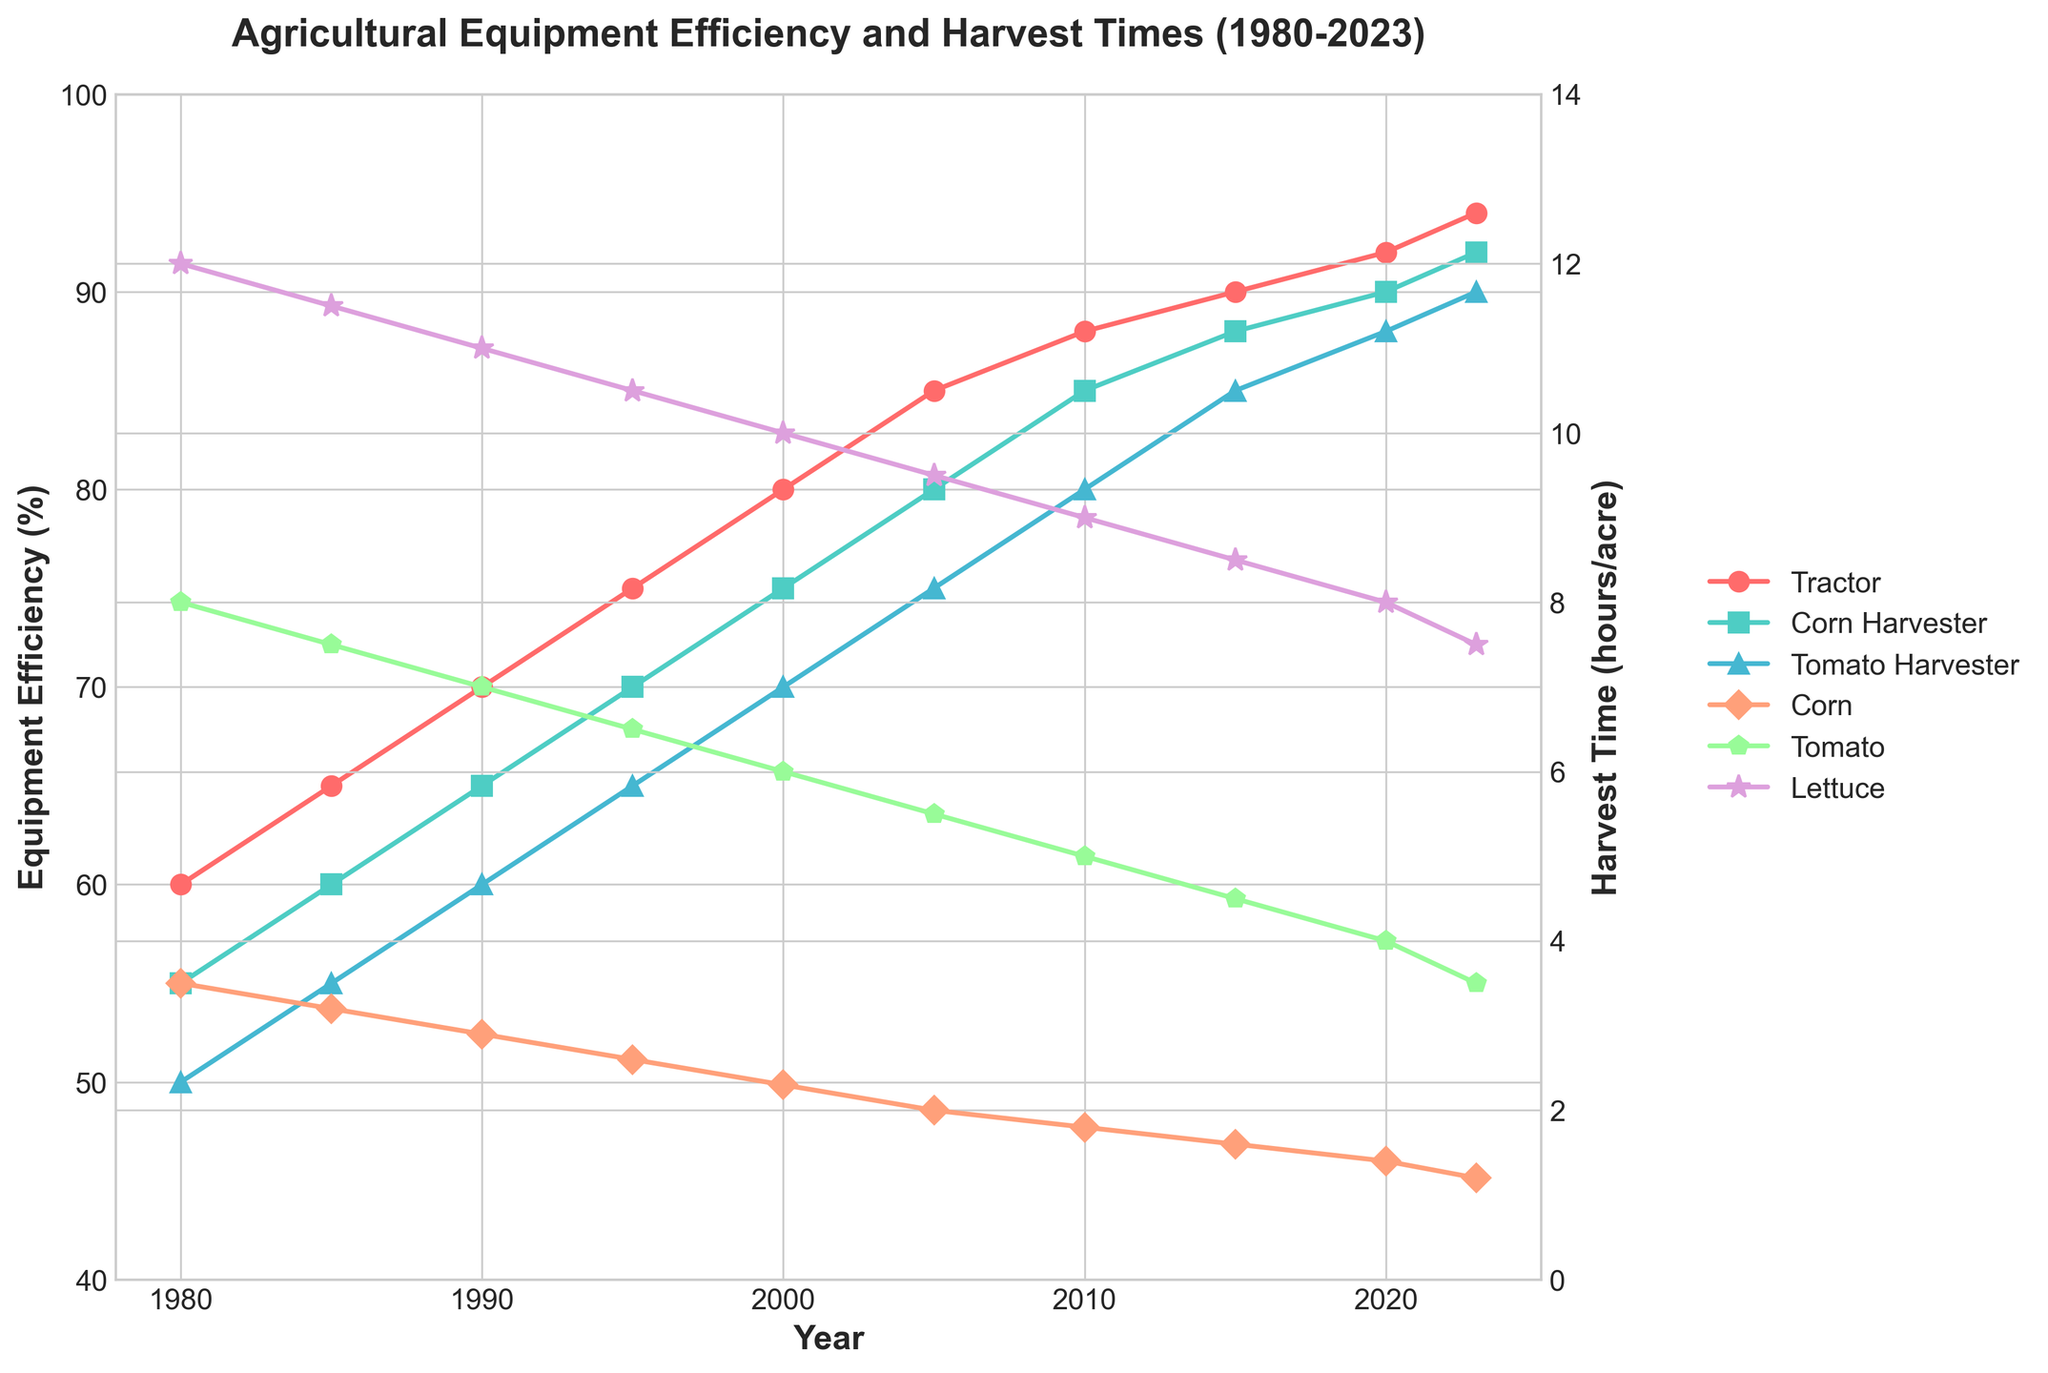What is the trend in tractor efficiency from 1980 to 2023? The tractor efficiency increases steadily over time from 60% in 1980 to 94% in 2023. Each data point shows a consistent rise, indicating a steady improvement in tractor efficiency.
Answer: Tractor efficiency steadily increases from 60% to 94% How does the cornharvester efficiency in 2000 compare to 2015? In 2000, the corn harvester efficiency is 75%. In 2015, it increases to 88%. Comparing these values, there is a noticeable increase in efficiency from 2000 to 2015.
Answer: Corn harvester efficiency increases from 75% to 88% Which year shows the biggest drop in lettuce harvest time compared to the previous year? Comparing each year's data, from 2015 to 2020, the lettuce harvest time dropped from 8.5 hours/acre to 8.0 hours/acre. This 0.5-hour drop is the largest seen in this period.
Answer: Between 2015 and 2020 What is the average improvement in tomato harvester efficiency every 5 years? From 1980 to 2023, tomato harvester efficiency improves from 50% to 90% over 43 years (2023-1980). The average improvement per year is (90-50)/43 = 0.93%. For every 5 years, it’s 0.93% * 5 = 4.65%.
Answer: Around 4.65% every 5 years Which crop saw the most significant reduction in harvest time from 1980 to 2023? Comparing the initial and final times for corn, tomato, and lettuce, Corn harvest time dropped from 3.5 hours/acre to 1.2, tomato from 8.0 to 3.5, and lettuce from 12.0 to 7.5 hours/acre. The largest change is in corn with a reduction of 2.3 hours/acre.
Answer: Corn What year did the corn harvester efficiency first reach 85%? The plot shows that corn harvester efficiency reaches 85% in the year 2010, as this is where the data point aligns with the 85% mark on the y-axis.
Answer: 2010 Compare the efficiency improvements between the corn harvester and the tomato harvester from 1990 to 2000. In 1990, corn harvester efficiency is 65% and in 2000, it is 75%, showing an increase of 10%. For the tomato harvester, the efficiency is 60% in 1990 and 70% in 2000, indicating the same 10% improvement.
Answer: Both improved by 10% Between which consecutive years did the tomato harvester efficiency see the greatest increase? By examining the data, the biggest increase in tomato harvester efficiency occurs between 2000 and 2005, where it increased from 70% to 75%.
Answer: Between 2000 and 2005 What is the relationship between equipment efficiency and harvest times for each crop? As equipment efficiency improves for tractors and harvesters, the harvest times for all crops (corn, tomato, lettuce) decrease consistently. This inverse relationship is evident as higher efficiency corresponds to shorter harvest times.
Answer: Higher efficiency results in shorter harvest times What can be inferred about the trend in agricultural technology over the years based on this data? Over the years, the continuous improvement in agricultural equipment efficiency and the corresponding decrease in harvest times suggest significant advancements in agricultural technology. These advancements increase productivity and reduce labor time.
Answer: Advancements in technology improve efficiency and reduce harvest times 